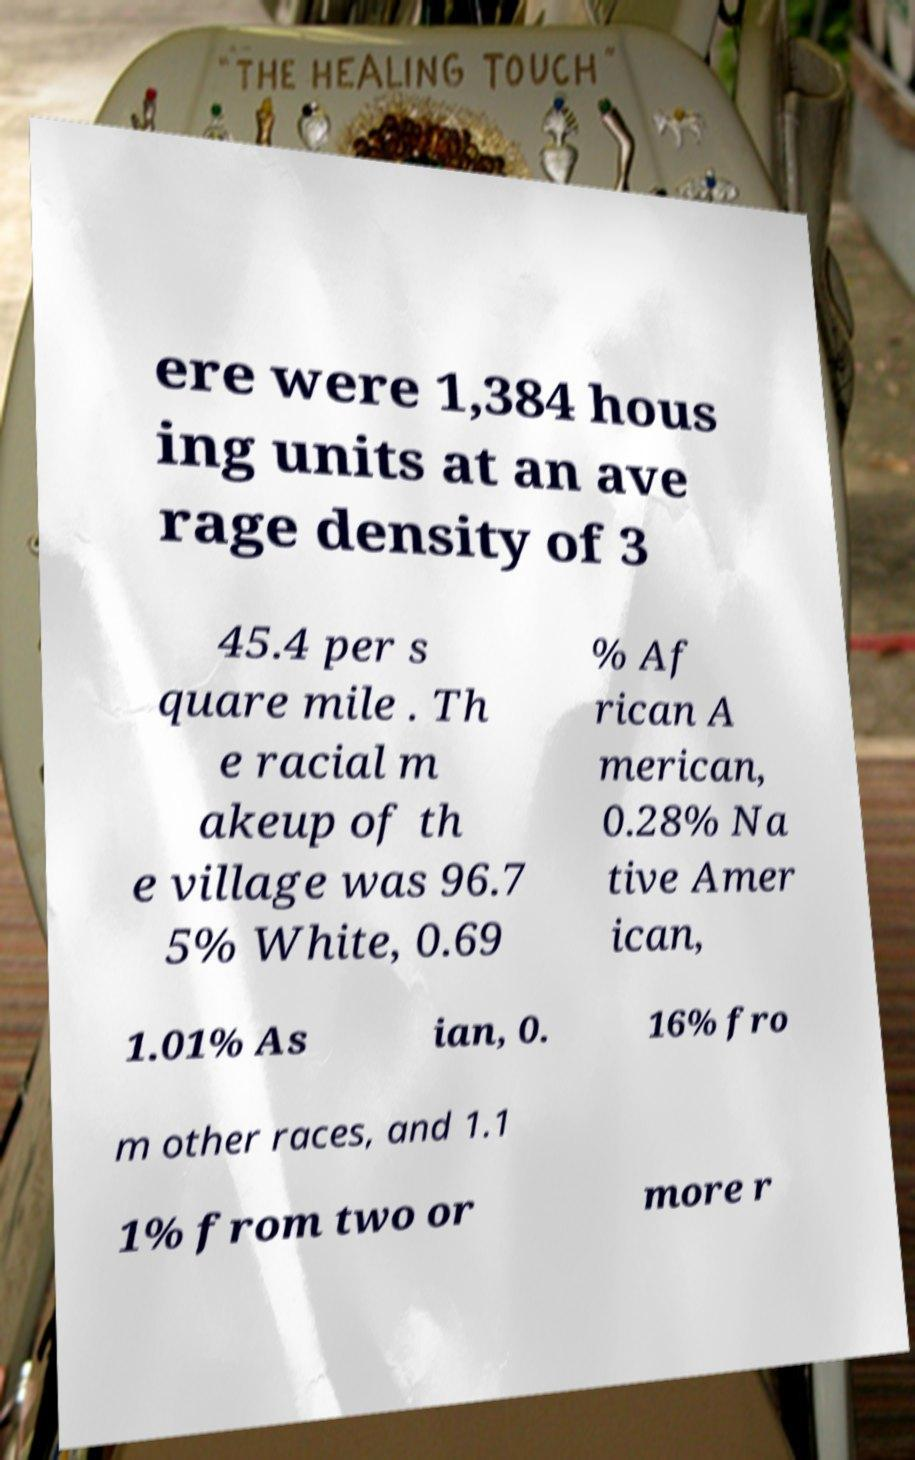Could you assist in decoding the text presented in this image and type it out clearly? ere were 1,384 hous ing units at an ave rage density of 3 45.4 per s quare mile . Th e racial m akeup of th e village was 96.7 5% White, 0.69 % Af rican A merican, 0.28% Na tive Amer ican, 1.01% As ian, 0. 16% fro m other races, and 1.1 1% from two or more r 